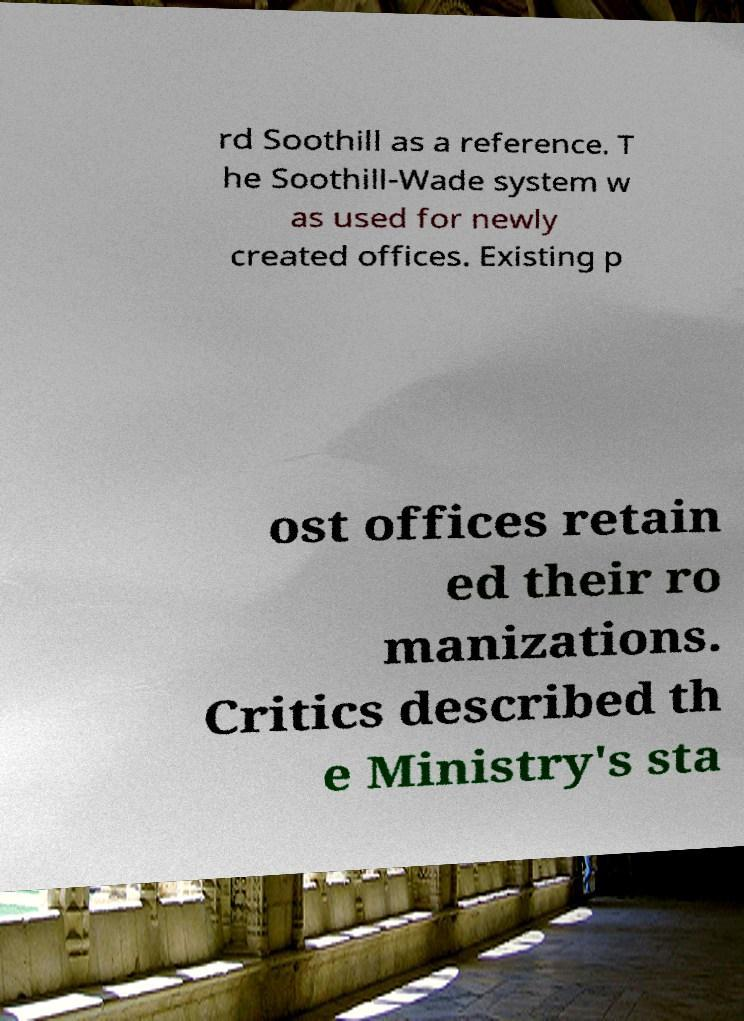Please identify and transcribe the text found in this image. rd Soothill as a reference. T he Soothill-Wade system w as used for newly created offices. Existing p ost offices retain ed their ro manizations. Critics described th e Ministry's sta 